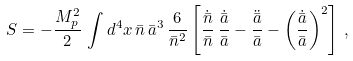Convert formula to latex. <formula><loc_0><loc_0><loc_500><loc_500>S = - \frac { M _ { p } ^ { 2 } } { 2 } \, \int d ^ { 4 } x \, \bar { n } \, \bar { a } ^ { 3 } \, \frac { 6 } { \bar { n } ^ { 2 } } \left [ \frac { \dot { \bar { n } } } { \bar { n } } \, \frac { \dot { \bar { a } } } { \bar { a } } - \frac { \ddot { \bar { a } } } { \bar { a } } - \left ( \frac { \dot { \bar { a } } } { \bar { a } } \right ) ^ { 2 } \right ] \, ,</formula> 